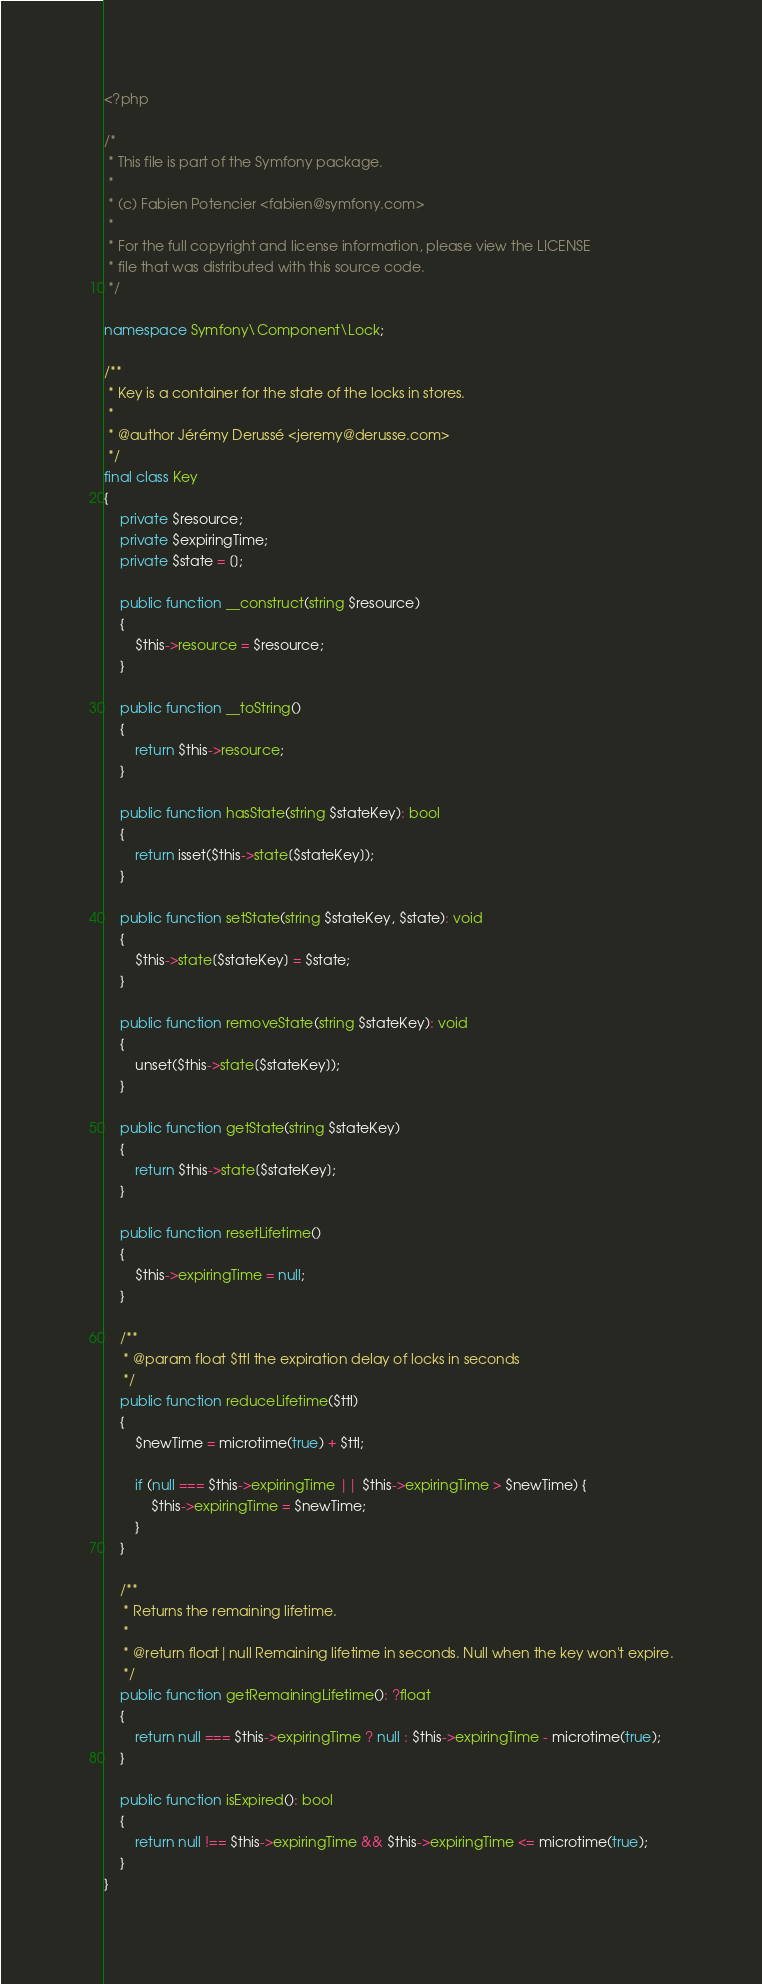<code> <loc_0><loc_0><loc_500><loc_500><_PHP_><?php

/*
 * This file is part of the Symfony package.
 *
 * (c) Fabien Potencier <fabien@symfony.com>
 *
 * For the full copyright and license information, please view the LICENSE
 * file that was distributed with this source code.
 */

namespace Symfony\Component\Lock;

/**
 * Key is a container for the state of the locks in stores.
 *
 * @author Jérémy Derussé <jeremy@derusse.com>
 */
final class Key
{
    private $resource;
    private $expiringTime;
    private $state = [];

    public function __construct(string $resource)
    {
        $this->resource = $resource;
    }

    public function __toString()
    {
        return $this->resource;
    }

    public function hasState(string $stateKey): bool
    {
        return isset($this->state[$stateKey]);
    }

    public function setState(string $stateKey, $state): void
    {
        $this->state[$stateKey] = $state;
    }

    public function removeState(string $stateKey): void
    {
        unset($this->state[$stateKey]);
    }

    public function getState(string $stateKey)
    {
        return $this->state[$stateKey];
    }

    public function resetLifetime()
    {
        $this->expiringTime = null;
    }

    /**
     * @param float $ttl the expiration delay of locks in seconds
     */
    public function reduceLifetime($ttl)
    {
        $newTime = microtime(true) + $ttl;

        if (null === $this->expiringTime || $this->expiringTime > $newTime) {
            $this->expiringTime = $newTime;
        }
    }

    /**
     * Returns the remaining lifetime.
     *
     * @return float|null Remaining lifetime in seconds. Null when the key won't expire.
     */
    public function getRemainingLifetime(): ?float
    {
        return null === $this->expiringTime ? null : $this->expiringTime - microtime(true);
    }

    public function isExpired(): bool
    {
        return null !== $this->expiringTime && $this->expiringTime <= microtime(true);
    }
}
</code> 